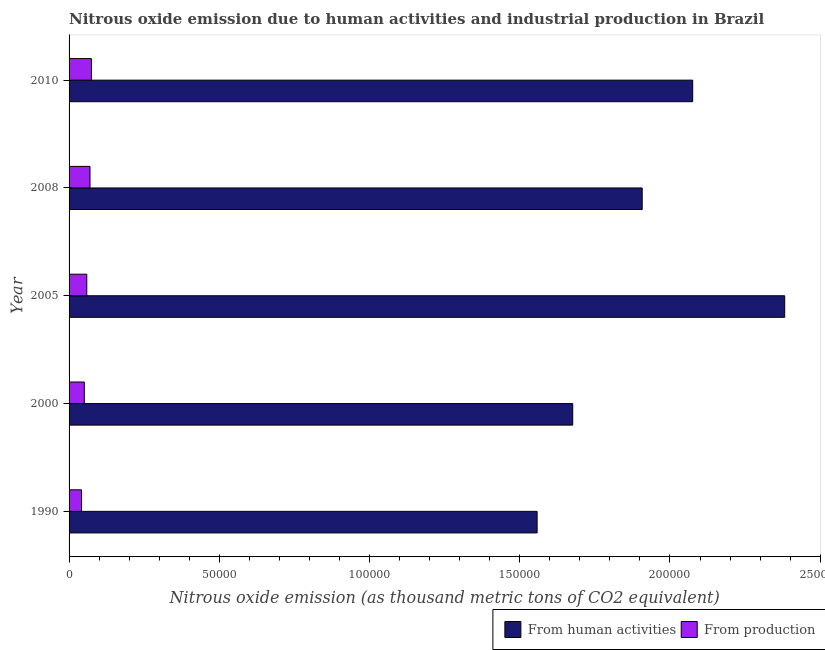How many different coloured bars are there?
Offer a terse response. 2. Are the number of bars on each tick of the Y-axis equal?
Keep it short and to the point. Yes. How many bars are there on the 3rd tick from the bottom?
Keep it short and to the point. 2. What is the amount of emissions generated from industries in 2000?
Keep it short and to the point. 5073.4. Across all years, what is the maximum amount of emissions from human activities?
Your answer should be very brief. 2.38e+05. Across all years, what is the minimum amount of emissions generated from industries?
Your answer should be compact. 4140.8. In which year was the amount of emissions generated from industries maximum?
Offer a terse response. 2010. In which year was the amount of emissions from human activities minimum?
Keep it short and to the point. 1990. What is the total amount of emissions generated from industries in the graph?
Offer a terse response. 2.95e+04. What is the difference between the amount of emissions generated from industries in 1990 and that in 2008?
Your answer should be very brief. -2827.1. What is the difference between the amount of emissions generated from industries in 2000 and the amount of emissions from human activities in 2010?
Provide a short and direct response. -2.03e+05. What is the average amount of emissions from human activities per year?
Your answer should be very brief. 1.92e+05. In the year 2005, what is the difference between the amount of emissions from human activities and amount of emissions generated from industries?
Keep it short and to the point. 2.32e+05. In how many years, is the amount of emissions generated from industries greater than 150000 thousand metric tons?
Offer a terse response. 0. What is the ratio of the amount of emissions generated from industries in 1990 to that in 2008?
Offer a terse response. 0.59. Is the amount of emissions generated from industries in 2008 less than that in 2010?
Provide a succinct answer. Yes. What is the difference between the highest and the second highest amount of emissions from human activities?
Your answer should be very brief. 3.06e+04. What is the difference between the highest and the lowest amount of emissions from human activities?
Provide a short and direct response. 8.24e+04. In how many years, is the amount of emissions generated from industries greater than the average amount of emissions generated from industries taken over all years?
Ensure brevity in your answer.  2. Is the sum of the amount of emissions from human activities in 1990 and 2005 greater than the maximum amount of emissions generated from industries across all years?
Ensure brevity in your answer.  Yes. What does the 1st bar from the top in 2010 represents?
Your response must be concise. From production. What does the 1st bar from the bottom in 2000 represents?
Ensure brevity in your answer.  From human activities. Are all the bars in the graph horizontal?
Give a very brief answer. Yes. How many years are there in the graph?
Keep it short and to the point. 5. What is the difference between two consecutive major ticks on the X-axis?
Ensure brevity in your answer.  5.00e+04. Does the graph contain any zero values?
Make the answer very short. No. Does the graph contain grids?
Make the answer very short. No. How many legend labels are there?
Offer a terse response. 2. What is the title of the graph?
Ensure brevity in your answer.  Nitrous oxide emission due to human activities and industrial production in Brazil. Does "Chemicals" appear as one of the legend labels in the graph?
Keep it short and to the point. No. What is the label or title of the X-axis?
Your answer should be compact. Nitrous oxide emission (as thousand metric tons of CO2 equivalent). What is the Nitrous oxide emission (as thousand metric tons of CO2 equivalent) in From human activities in 1990?
Ensure brevity in your answer.  1.56e+05. What is the Nitrous oxide emission (as thousand metric tons of CO2 equivalent) of From production in 1990?
Provide a succinct answer. 4140.8. What is the Nitrous oxide emission (as thousand metric tons of CO2 equivalent) of From human activities in 2000?
Offer a terse response. 1.68e+05. What is the Nitrous oxide emission (as thousand metric tons of CO2 equivalent) of From production in 2000?
Your answer should be very brief. 5073.4. What is the Nitrous oxide emission (as thousand metric tons of CO2 equivalent) in From human activities in 2005?
Offer a very short reply. 2.38e+05. What is the Nitrous oxide emission (as thousand metric tons of CO2 equivalent) of From production in 2005?
Provide a succinct answer. 5897.3. What is the Nitrous oxide emission (as thousand metric tons of CO2 equivalent) in From human activities in 2008?
Provide a succinct answer. 1.91e+05. What is the Nitrous oxide emission (as thousand metric tons of CO2 equivalent) of From production in 2008?
Ensure brevity in your answer.  6967.9. What is the Nitrous oxide emission (as thousand metric tons of CO2 equivalent) of From human activities in 2010?
Ensure brevity in your answer.  2.08e+05. What is the Nitrous oxide emission (as thousand metric tons of CO2 equivalent) in From production in 2010?
Provide a succinct answer. 7440.7. Across all years, what is the maximum Nitrous oxide emission (as thousand metric tons of CO2 equivalent) in From human activities?
Make the answer very short. 2.38e+05. Across all years, what is the maximum Nitrous oxide emission (as thousand metric tons of CO2 equivalent) of From production?
Ensure brevity in your answer.  7440.7. Across all years, what is the minimum Nitrous oxide emission (as thousand metric tons of CO2 equivalent) of From human activities?
Your answer should be compact. 1.56e+05. Across all years, what is the minimum Nitrous oxide emission (as thousand metric tons of CO2 equivalent) in From production?
Your answer should be very brief. 4140.8. What is the total Nitrous oxide emission (as thousand metric tons of CO2 equivalent) in From human activities in the graph?
Offer a very short reply. 9.60e+05. What is the total Nitrous oxide emission (as thousand metric tons of CO2 equivalent) of From production in the graph?
Provide a succinct answer. 2.95e+04. What is the difference between the Nitrous oxide emission (as thousand metric tons of CO2 equivalent) of From human activities in 1990 and that in 2000?
Provide a succinct answer. -1.19e+04. What is the difference between the Nitrous oxide emission (as thousand metric tons of CO2 equivalent) in From production in 1990 and that in 2000?
Offer a very short reply. -932.6. What is the difference between the Nitrous oxide emission (as thousand metric tons of CO2 equivalent) of From human activities in 1990 and that in 2005?
Ensure brevity in your answer.  -8.24e+04. What is the difference between the Nitrous oxide emission (as thousand metric tons of CO2 equivalent) of From production in 1990 and that in 2005?
Offer a very short reply. -1756.5. What is the difference between the Nitrous oxide emission (as thousand metric tons of CO2 equivalent) in From human activities in 1990 and that in 2008?
Give a very brief answer. -3.50e+04. What is the difference between the Nitrous oxide emission (as thousand metric tons of CO2 equivalent) in From production in 1990 and that in 2008?
Provide a short and direct response. -2827.1. What is the difference between the Nitrous oxide emission (as thousand metric tons of CO2 equivalent) of From human activities in 1990 and that in 2010?
Keep it short and to the point. -5.18e+04. What is the difference between the Nitrous oxide emission (as thousand metric tons of CO2 equivalent) of From production in 1990 and that in 2010?
Provide a short and direct response. -3299.9. What is the difference between the Nitrous oxide emission (as thousand metric tons of CO2 equivalent) in From human activities in 2000 and that in 2005?
Give a very brief answer. -7.06e+04. What is the difference between the Nitrous oxide emission (as thousand metric tons of CO2 equivalent) of From production in 2000 and that in 2005?
Provide a short and direct response. -823.9. What is the difference between the Nitrous oxide emission (as thousand metric tons of CO2 equivalent) of From human activities in 2000 and that in 2008?
Provide a succinct answer. -2.31e+04. What is the difference between the Nitrous oxide emission (as thousand metric tons of CO2 equivalent) of From production in 2000 and that in 2008?
Provide a short and direct response. -1894.5. What is the difference between the Nitrous oxide emission (as thousand metric tons of CO2 equivalent) in From human activities in 2000 and that in 2010?
Ensure brevity in your answer.  -3.99e+04. What is the difference between the Nitrous oxide emission (as thousand metric tons of CO2 equivalent) in From production in 2000 and that in 2010?
Offer a very short reply. -2367.3. What is the difference between the Nitrous oxide emission (as thousand metric tons of CO2 equivalent) of From human activities in 2005 and that in 2008?
Provide a short and direct response. 4.74e+04. What is the difference between the Nitrous oxide emission (as thousand metric tons of CO2 equivalent) of From production in 2005 and that in 2008?
Give a very brief answer. -1070.6. What is the difference between the Nitrous oxide emission (as thousand metric tons of CO2 equivalent) in From human activities in 2005 and that in 2010?
Ensure brevity in your answer.  3.06e+04. What is the difference between the Nitrous oxide emission (as thousand metric tons of CO2 equivalent) in From production in 2005 and that in 2010?
Offer a terse response. -1543.4. What is the difference between the Nitrous oxide emission (as thousand metric tons of CO2 equivalent) of From human activities in 2008 and that in 2010?
Offer a terse response. -1.68e+04. What is the difference between the Nitrous oxide emission (as thousand metric tons of CO2 equivalent) in From production in 2008 and that in 2010?
Your answer should be very brief. -472.8. What is the difference between the Nitrous oxide emission (as thousand metric tons of CO2 equivalent) of From human activities in 1990 and the Nitrous oxide emission (as thousand metric tons of CO2 equivalent) of From production in 2000?
Keep it short and to the point. 1.51e+05. What is the difference between the Nitrous oxide emission (as thousand metric tons of CO2 equivalent) in From human activities in 1990 and the Nitrous oxide emission (as thousand metric tons of CO2 equivalent) in From production in 2005?
Your response must be concise. 1.50e+05. What is the difference between the Nitrous oxide emission (as thousand metric tons of CO2 equivalent) of From human activities in 1990 and the Nitrous oxide emission (as thousand metric tons of CO2 equivalent) of From production in 2008?
Keep it short and to the point. 1.49e+05. What is the difference between the Nitrous oxide emission (as thousand metric tons of CO2 equivalent) in From human activities in 1990 and the Nitrous oxide emission (as thousand metric tons of CO2 equivalent) in From production in 2010?
Offer a terse response. 1.48e+05. What is the difference between the Nitrous oxide emission (as thousand metric tons of CO2 equivalent) in From human activities in 2000 and the Nitrous oxide emission (as thousand metric tons of CO2 equivalent) in From production in 2005?
Ensure brevity in your answer.  1.62e+05. What is the difference between the Nitrous oxide emission (as thousand metric tons of CO2 equivalent) of From human activities in 2000 and the Nitrous oxide emission (as thousand metric tons of CO2 equivalent) of From production in 2008?
Provide a succinct answer. 1.61e+05. What is the difference between the Nitrous oxide emission (as thousand metric tons of CO2 equivalent) of From human activities in 2000 and the Nitrous oxide emission (as thousand metric tons of CO2 equivalent) of From production in 2010?
Give a very brief answer. 1.60e+05. What is the difference between the Nitrous oxide emission (as thousand metric tons of CO2 equivalent) of From human activities in 2005 and the Nitrous oxide emission (as thousand metric tons of CO2 equivalent) of From production in 2008?
Your answer should be compact. 2.31e+05. What is the difference between the Nitrous oxide emission (as thousand metric tons of CO2 equivalent) in From human activities in 2005 and the Nitrous oxide emission (as thousand metric tons of CO2 equivalent) in From production in 2010?
Your answer should be very brief. 2.31e+05. What is the difference between the Nitrous oxide emission (as thousand metric tons of CO2 equivalent) in From human activities in 2008 and the Nitrous oxide emission (as thousand metric tons of CO2 equivalent) in From production in 2010?
Ensure brevity in your answer.  1.83e+05. What is the average Nitrous oxide emission (as thousand metric tons of CO2 equivalent) of From human activities per year?
Your answer should be very brief. 1.92e+05. What is the average Nitrous oxide emission (as thousand metric tons of CO2 equivalent) of From production per year?
Offer a very short reply. 5904.02. In the year 1990, what is the difference between the Nitrous oxide emission (as thousand metric tons of CO2 equivalent) in From human activities and Nitrous oxide emission (as thousand metric tons of CO2 equivalent) in From production?
Make the answer very short. 1.52e+05. In the year 2000, what is the difference between the Nitrous oxide emission (as thousand metric tons of CO2 equivalent) in From human activities and Nitrous oxide emission (as thousand metric tons of CO2 equivalent) in From production?
Your response must be concise. 1.63e+05. In the year 2005, what is the difference between the Nitrous oxide emission (as thousand metric tons of CO2 equivalent) of From human activities and Nitrous oxide emission (as thousand metric tons of CO2 equivalent) of From production?
Make the answer very short. 2.32e+05. In the year 2008, what is the difference between the Nitrous oxide emission (as thousand metric tons of CO2 equivalent) of From human activities and Nitrous oxide emission (as thousand metric tons of CO2 equivalent) of From production?
Your answer should be very brief. 1.84e+05. In the year 2010, what is the difference between the Nitrous oxide emission (as thousand metric tons of CO2 equivalent) in From human activities and Nitrous oxide emission (as thousand metric tons of CO2 equivalent) in From production?
Your answer should be very brief. 2.00e+05. What is the ratio of the Nitrous oxide emission (as thousand metric tons of CO2 equivalent) of From human activities in 1990 to that in 2000?
Give a very brief answer. 0.93. What is the ratio of the Nitrous oxide emission (as thousand metric tons of CO2 equivalent) in From production in 1990 to that in 2000?
Ensure brevity in your answer.  0.82. What is the ratio of the Nitrous oxide emission (as thousand metric tons of CO2 equivalent) in From human activities in 1990 to that in 2005?
Give a very brief answer. 0.65. What is the ratio of the Nitrous oxide emission (as thousand metric tons of CO2 equivalent) in From production in 1990 to that in 2005?
Ensure brevity in your answer.  0.7. What is the ratio of the Nitrous oxide emission (as thousand metric tons of CO2 equivalent) in From human activities in 1990 to that in 2008?
Provide a succinct answer. 0.82. What is the ratio of the Nitrous oxide emission (as thousand metric tons of CO2 equivalent) in From production in 1990 to that in 2008?
Ensure brevity in your answer.  0.59. What is the ratio of the Nitrous oxide emission (as thousand metric tons of CO2 equivalent) in From human activities in 1990 to that in 2010?
Offer a very short reply. 0.75. What is the ratio of the Nitrous oxide emission (as thousand metric tons of CO2 equivalent) of From production in 1990 to that in 2010?
Ensure brevity in your answer.  0.56. What is the ratio of the Nitrous oxide emission (as thousand metric tons of CO2 equivalent) of From human activities in 2000 to that in 2005?
Offer a very short reply. 0.7. What is the ratio of the Nitrous oxide emission (as thousand metric tons of CO2 equivalent) in From production in 2000 to that in 2005?
Your answer should be compact. 0.86. What is the ratio of the Nitrous oxide emission (as thousand metric tons of CO2 equivalent) of From human activities in 2000 to that in 2008?
Offer a very short reply. 0.88. What is the ratio of the Nitrous oxide emission (as thousand metric tons of CO2 equivalent) of From production in 2000 to that in 2008?
Offer a terse response. 0.73. What is the ratio of the Nitrous oxide emission (as thousand metric tons of CO2 equivalent) of From human activities in 2000 to that in 2010?
Offer a terse response. 0.81. What is the ratio of the Nitrous oxide emission (as thousand metric tons of CO2 equivalent) in From production in 2000 to that in 2010?
Ensure brevity in your answer.  0.68. What is the ratio of the Nitrous oxide emission (as thousand metric tons of CO2 equivalent) of From human activities in 2005 to that in 2008?
Your response must be concise. 1.25. What is the ratio of the Nitrous oxide emission (as thousand metric tons of CO2 equivalent) of From production in 2005 to that in 2008?
Your answer should be compact. 0.85. What is the ratio of the Nitrous oxide emission (as thousand metric tons of CO2 equivalent) in From human activities in 2005 to that in 2010?
Offer a very short reply. 1.15. What is the ratio of the Nitrous oxide emission (as thousand metric tons of CO2 equivalent) of From production in 2005 to that in 2010?
Ensure brevity in your answer.  0.79. What is the ratio of the Nitrous oxide emission (as thousand metric tons of CO2 equivalent) of From human activities in 2008 to that in 2010?
Give a very brief answer. 0.92. What is the ratio of the Nitrous oxide emission (as thousand metric tons of CO2 equivalent) in From production in 2008 to that in 2010?
Make the answer very short. 0.94. What is the difference between the highest and the second highest Nitrous oxide emission (as thousand metric tons of CO2 equivalent) in From human activities?
Make the answer very short. 3.06e+04. What is the difference between the highest and the second highest Nitrous oxide emission (as thousand metric tons of CO2 equivalent) of From production?
Your answer should be compact. 472.8. What is the difference between the highest and the lowest Nitrous oxide emission (as thousand metric tons of CO2 equivalent) in From human activities?
Your answer should be compact. 8.24e+04. What is the difference between the highest and the lowest Nitrous oxide emission (as thousand metric tons of CO2 equivalent) in From production?
Make the answer very short. 3299.9. 